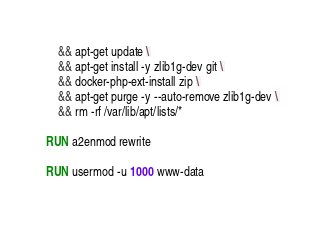<code> <loc_0><loc_0><loc_500><loc_500><_Dockerfile_>    && apt-get update \
    && apt-get install -y zlib1g-dev git \
    && docker-php-ext-install zip \
    && apt-get purge -y --auto-remove zlib1g-dev \
    && rm -rf /var/lib/apt/lists/*

RUN a2enmod rewrite

RUN usermod -u 1000 www-data
</code> 